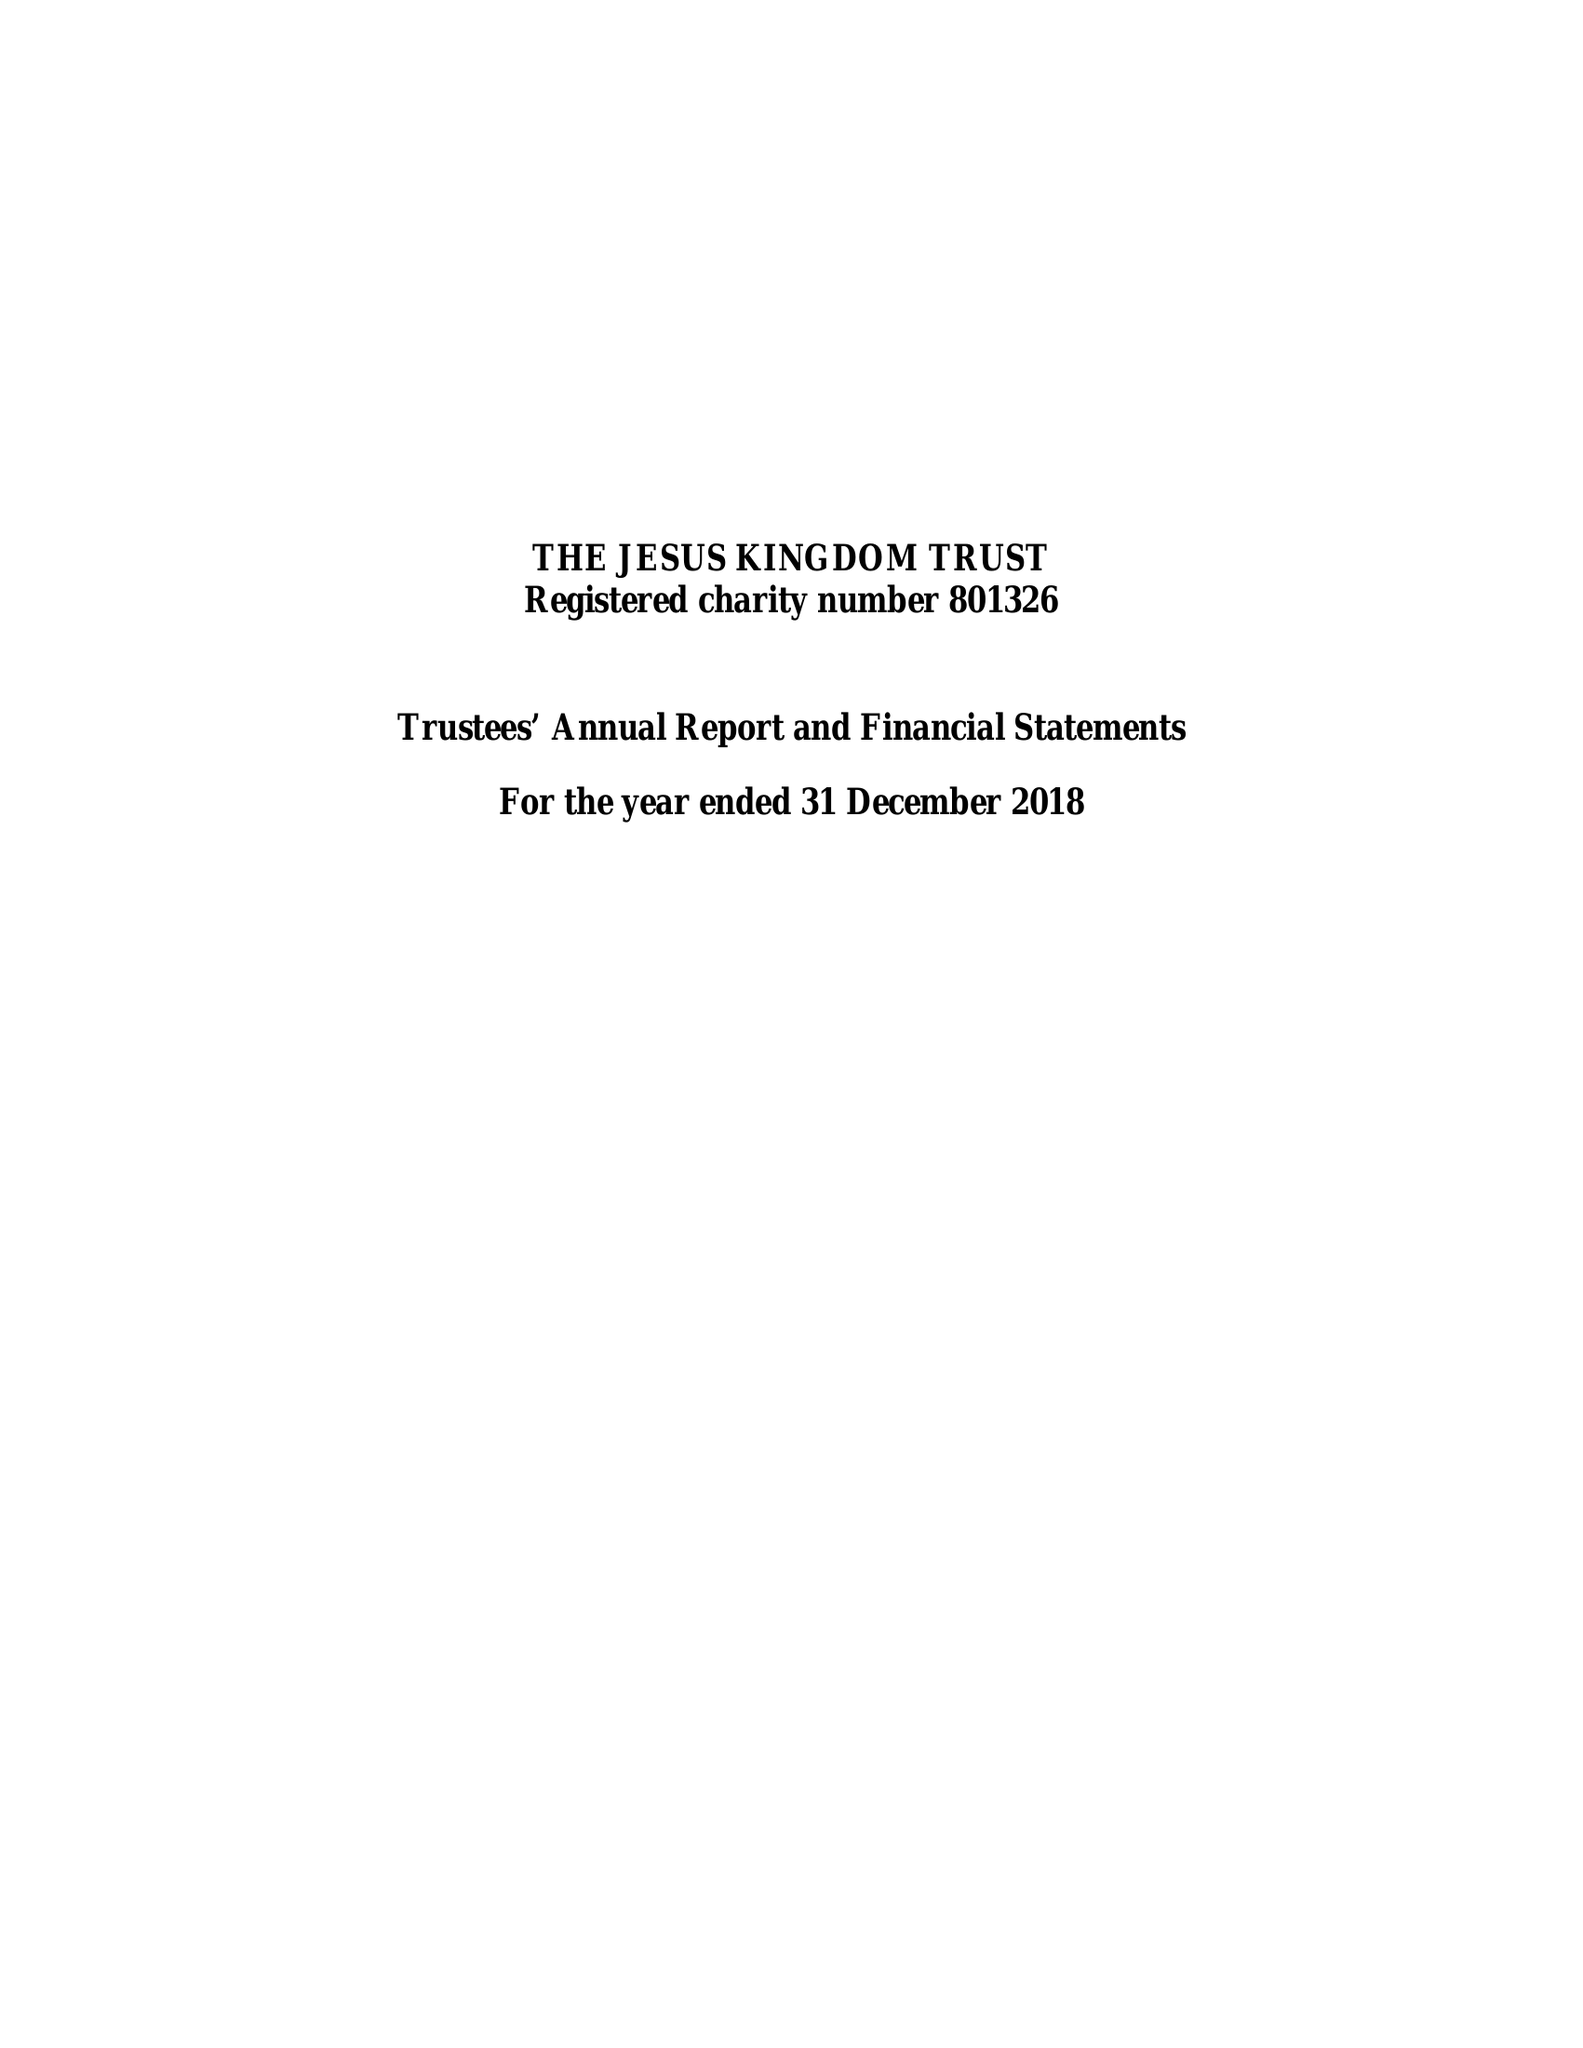What is the value for the report_date?
Answer the question using a single word or phrase. 2018-12-31 